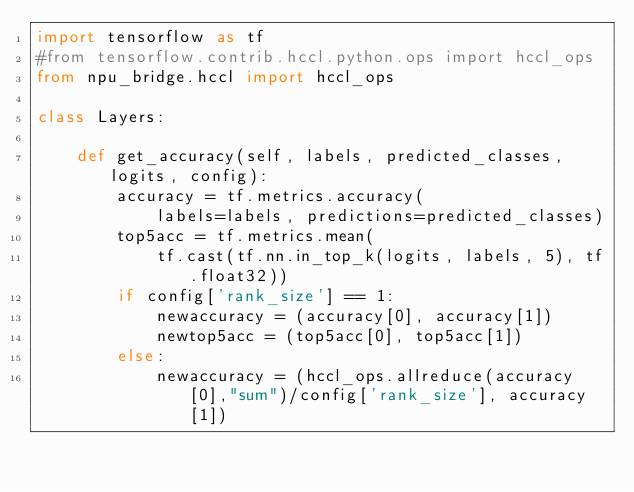<code> <loc_0><loc_0><loc_500><loc_500><_Python_>import tensorflow as tf
#from tensorflow.contrib.hccl.python.ops import hccl_ops
from npu_bridge.hccl import hccl_ops

class Layers:
 
    def get_accuracy(self, labels, predicted_classes, logits, config):
        accuracy = tf.metrics.accuracy(
            labels=labels, predictions=predicted_classes) 
        top5acc = tf.metrics.mean(
            tf.cast(tf.nn.in_top_k(logits, labels, 5), tf.float32))
        if config['rank_size'] == 1:
            newaccuracy = (accuracy[0], accuracy[1])
            newtop5acc = (top5acc[0], top5acc[1])
        else:
            newaccuracy = (hccl_ops.allreduce(accuracy[0],"sum")/config['rank_size'], accuracy[1])</code> 